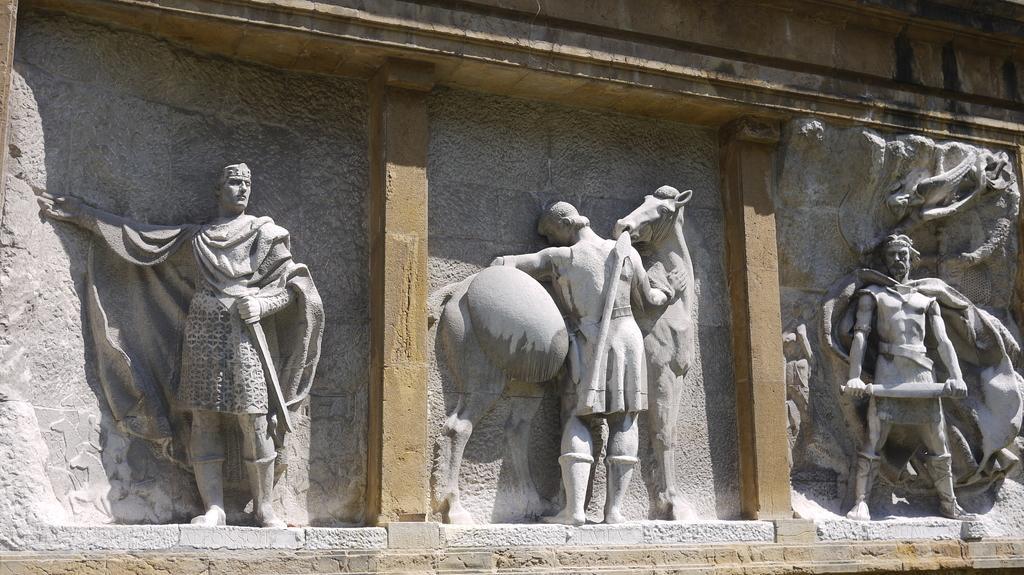Please provide a concise description of this image. In this image we can see sculptures, pillars and the wall. 